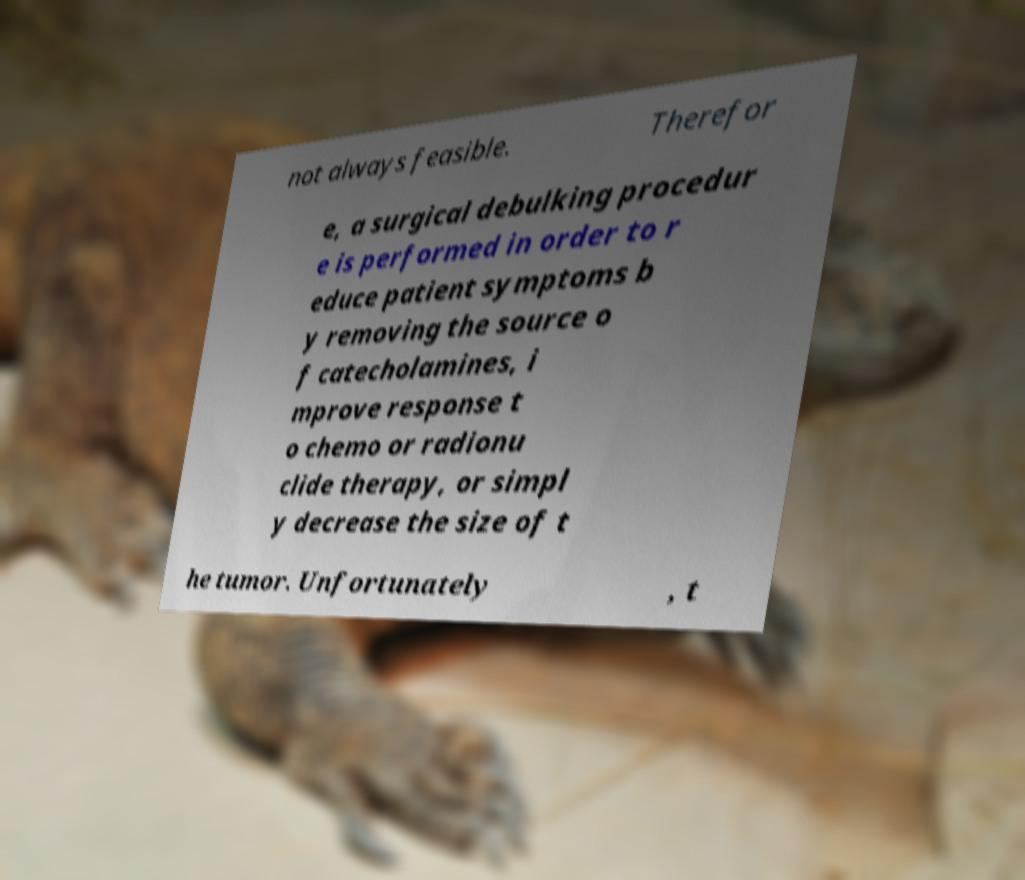What messages or text are displayed in this image? I need them in a readable, typed format. not always feasible. Therefor e, a surgical debulking procedur e is performed in order to r educe patient symptoms b y removing the source o f catecholamines, i mprove response t o chemo or radionu clide therapy, or simpl y decrease the size of t he tumor. Unfortunately , t 